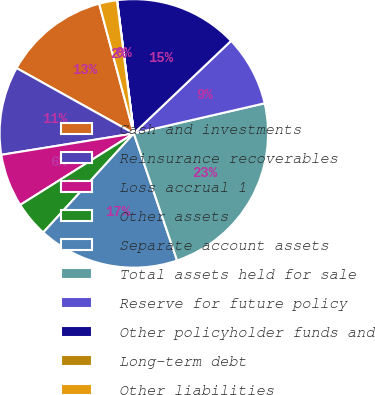Convert chart to OTSL. <chart><loc_0><loc_0><loc_500><loc_500><pie_chart><fcel>Cash and investments<fcel>Reinsurance recoverables<fcel>Loss accrual 1<fcel>Other assets<fcel>Separate account assets<fcel>Total assets held for sale<fcel>Reserve for future policy<fcel>Other policyholder funds and<fcel>Long-term debt<fcel>Other liabilities<nl><fcel>12.76%<fcel>10.64%<fcel>6.39%<fcel>4.27%<fcel>17.01%<fcel>23.38%<fcel>8.51%<fcel>14.88%<fcel>0.02%<fcel>2.14%<nl></chart> 